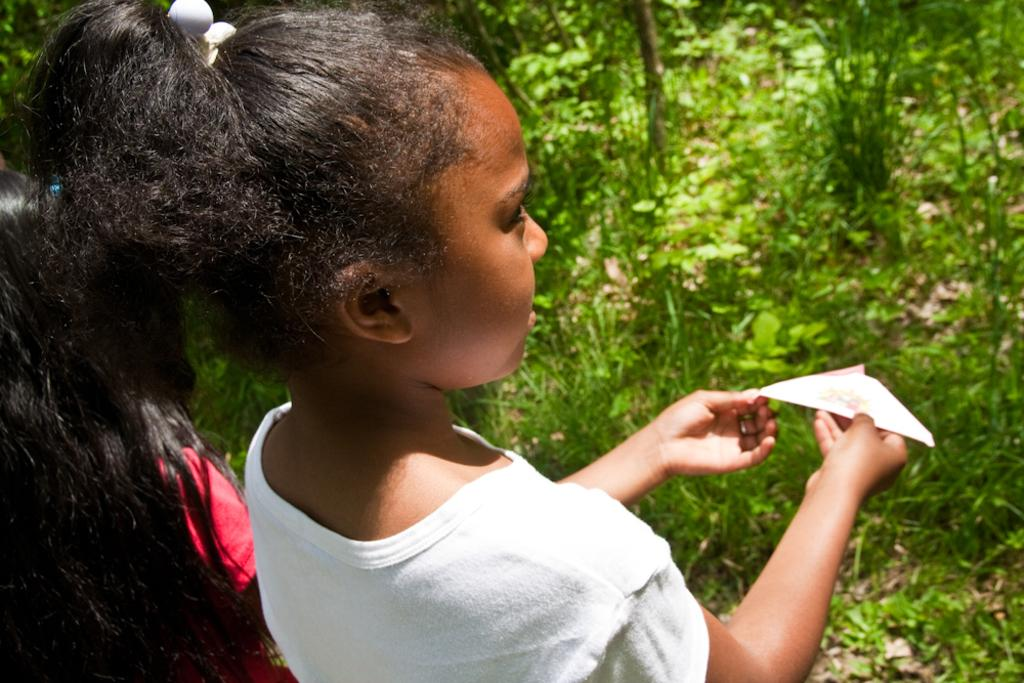What is the girl in the image doing? There is a girl standing in the image, holding a paper cloth in her hand. Can you describe the girl's surroundings? There is another girl beside the first girl, grass is visible in front of the girls, and trees are present in the image. What type of rice is being used by the carpenter in the image? There is no carpenter or rice present in the image. What kind of paste is being applied to the trees in the image? There is no paste being applied to the trees in the image. 